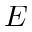<formula> <loc_0><loc_0><loc_500><loc_500>E</formula> 